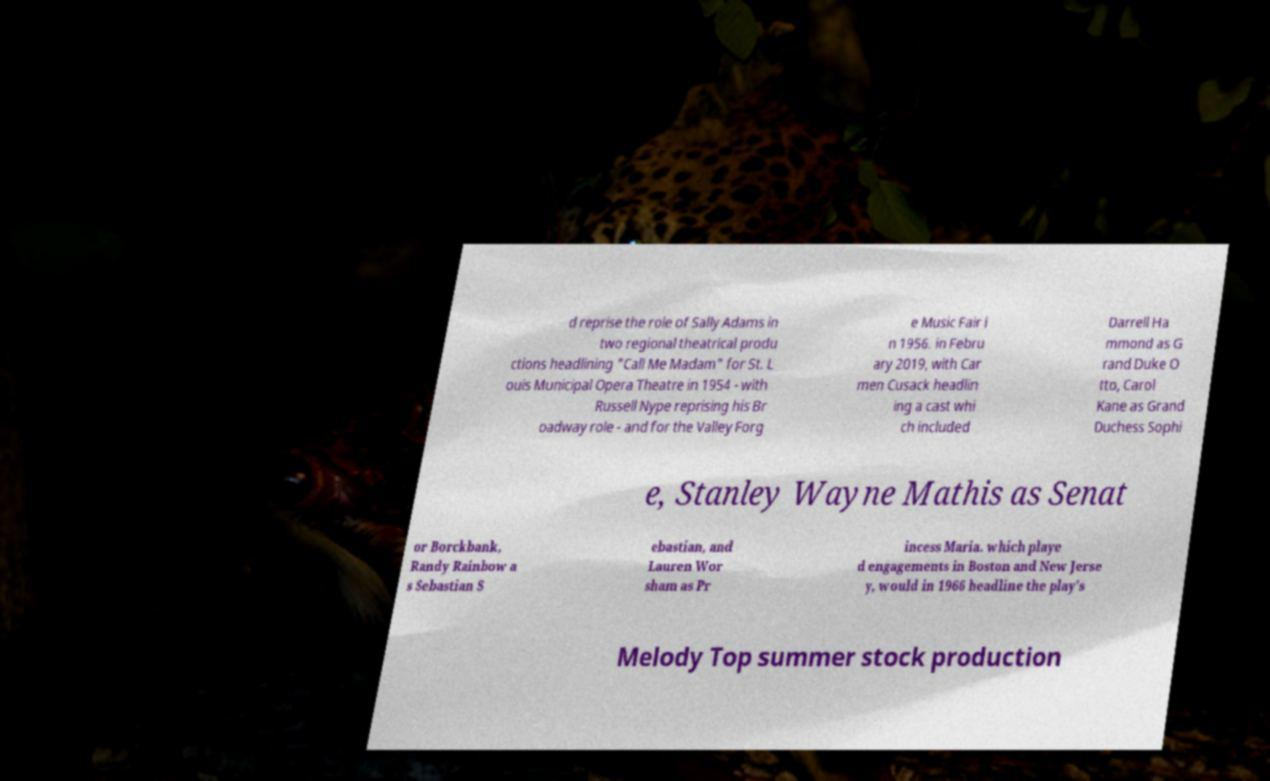Please identify and transcribe the text found in this image. d reprise the role of Sally Adams in two regional theatrical produ ctions headlining "Call Me Madam" for St. L ouis Municipal Opera Theatre in 1954 - with Russell Nype reprising his Br oadway role - and for the Valley Forg e Music Fair i n 1956. in Febru ary 2019, with Car men Cusack headlin ing a cast whi ch included Darrell Ha mmond as G rand Duke O tto, Carol Kane as Grand Duchess Sophi e, Stanley Wayne Mathis as Senat or Borckbank, Randy Rainbow a s Sebastian S ebastian, and Lauren Wor sham as Pr incess Maria. which playe d engagements in Boston and New Jerse y, would in 1966 headline the play's Melody Top summer stock production 